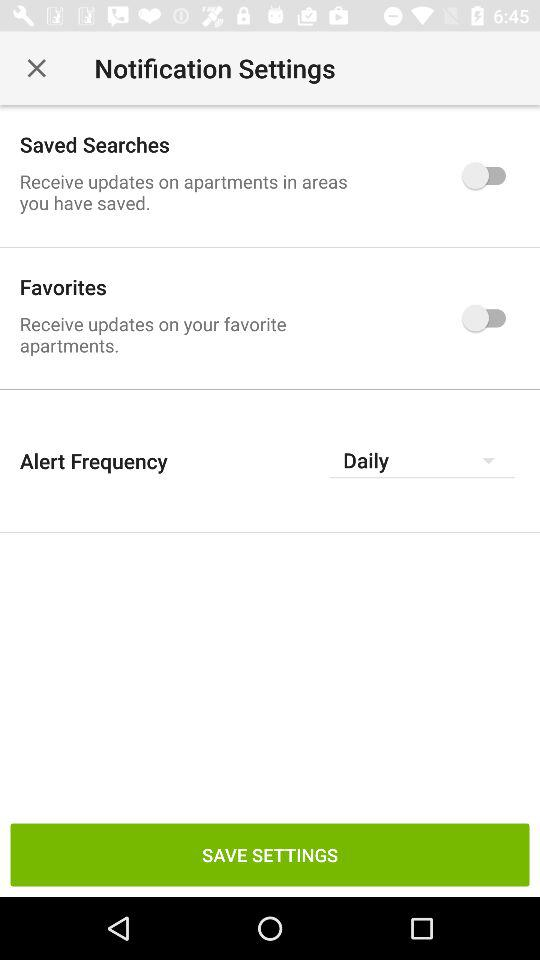Which option is selected in "Alert Frequency"? The option that is selected in "Alert Frequency" is "Daily". 